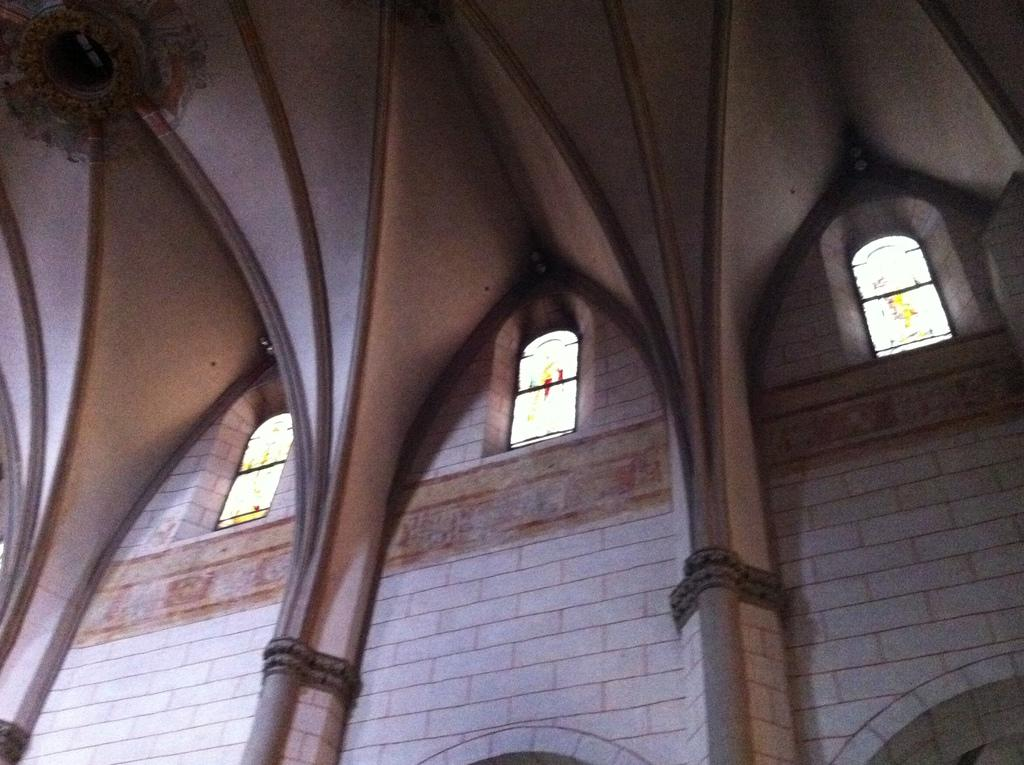What type of location is depicted in the image? The image shows an inner view of a building. What architectural feature can be seen in the image? There are windows visible in the image. What color is the wall in the image? The wall in the image is white. Can you describe the object in the top left corner of the image? Unfortunately, the facts provided do not give enough information to describe the object in the top left corner of the image. What time of day is it in the image, and how does the skate help with learning? The facts provided do not give any information about the time of day or the presence of a skate in the image. Therefore, we cannot answer these questions. 